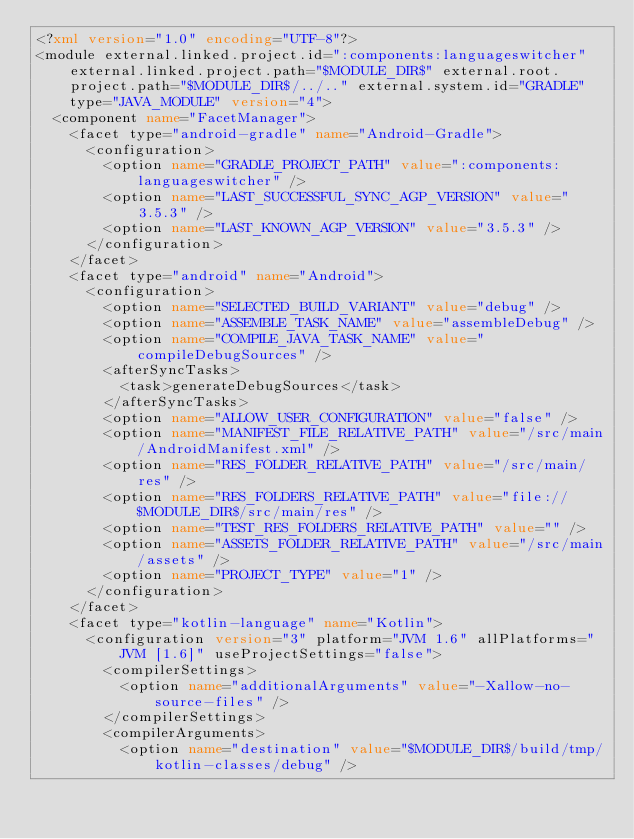Convert code to text. <code><loc_0><loc_0><loc_500><loc_500><_XML_><?xml version="1.0" encoding="UTF-8"?>
<module external.linked.project.id=":components:languageswitcher" external.linked.project.path="$MODULE_DIR$" external.root.project.path="$MODULE_DIR$/../.." external.system.id="GRADLE" type="JAVA_MODULE" version="4">
  <component name="FacetManager">
    <facet type="android-gradle" name="Android-Gradle">
      <configuration>
        <option name="GRADLE_PROJECT_PATH" value=":components:languageswitcher" />
        <option name="LAST_SUCCESSFUL_SYNC_AGP_VERSION" value="3.5.3" />
        <option name="LAST_KNOWN_AGP_VERSION" value="3.5.3" />
      </configuration>
    </facet>
    <facet type="android" name="Android">
      <configuration>
        <option name="SELECTED_BUILD_VARIANT" value="debug" />
        <option name="ASSEMBLE_TASK_NAME" value="assembleDebug" />
        <option name="COMPILE_JAVA_TASK_NAME" value="compileDebugSources" />
        <afterSyncTasks>
          <task>generateDebugSources</task>
        </afterSyncTasks>
        <option name="ALLOW_USER_CONFIGURATION" value="false" />
        <option name="MANIFEST_FILE_RELATIVE_PATH" value="/src/main/AndroidManifest.xml" />
        <option name="RES_FOLDER_RELATIVE_PATH" value="/src/main/res" />
        <option name="RES_FOLDERS_RELATIVE_PATH" value="file://$MODULE_DIR$/src/main/res" />
        <option name="TEST_RES_FOLDERS_RELATIVE_PATH" value="" />
        <option name="ASSETS_FOLDER_RELATIVE_PATH" value="/src/main/assets" />
        <option name="PROJECT_TYPE" value="1" />
      </configuration>
    </facet>
    <facet type="kotlin-language" name="Kotlin">
      <configuration version="3" platform="JVM 1.6" allPlatforms="JVM [1.6]" useProjectSettings="false">
        <compilerSettings>
          <option name="additionalArguments" value="-Xallow-no-source-files" />
        </compilerSettings>
        <compilerArguments>
          <option name="destination" value="$MODULE_DIR$/build/tmp/kotlin-classes/debug" /></code> 